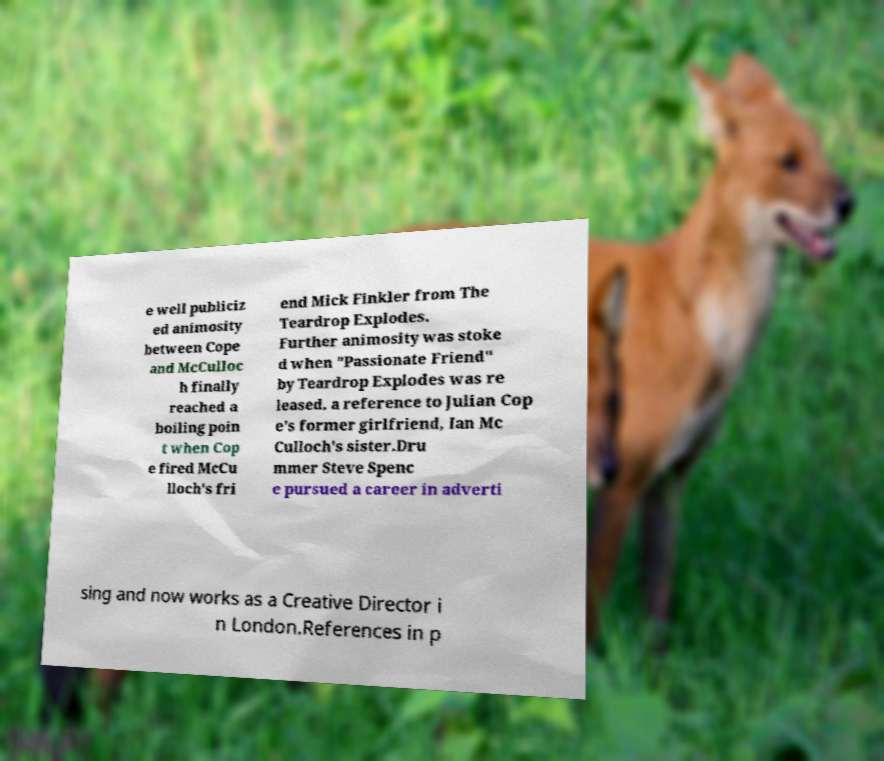Can you read and provide the text displayed in the image?This photo seems to have some interesting text. Can you extract and type it out for me? e well publiciz ed animosity between Cope and McCulloc h finally reached a boiling poin t when Cop e fired McCu lloch's fri end Mick Finkler from The Teardrop Explodes. Further animosity was stoke d when "Passionate Friend" by Teardrop Explodes was re leased, a reference to Julian Cop e's former girlfriend, Ian Mc Culloch's sister.Dru mmer Steve Spenc e pursued a career in adverti sing and now works as a Creative Director i n London.References in p 